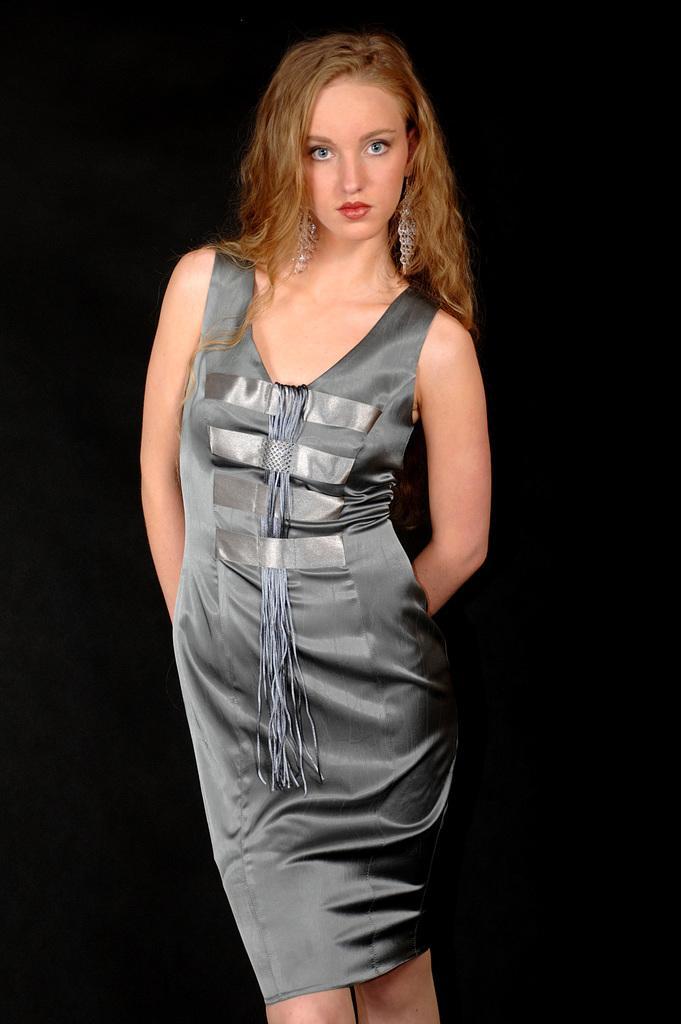In one or two sentences, can you explain what this image depicts? In the image a woman is standing and watching. 